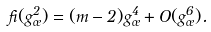Convert formula to latex. <formula><loc_0><loc_0><loc_500><loc_500>\beta ( g _ { \sigma } ^ { 2 } ) = ( m - 2 ) g _ { \sigma } ^ { 4 } + O ( g _ { \sigma } ^ { 6 } ) .</formula> 